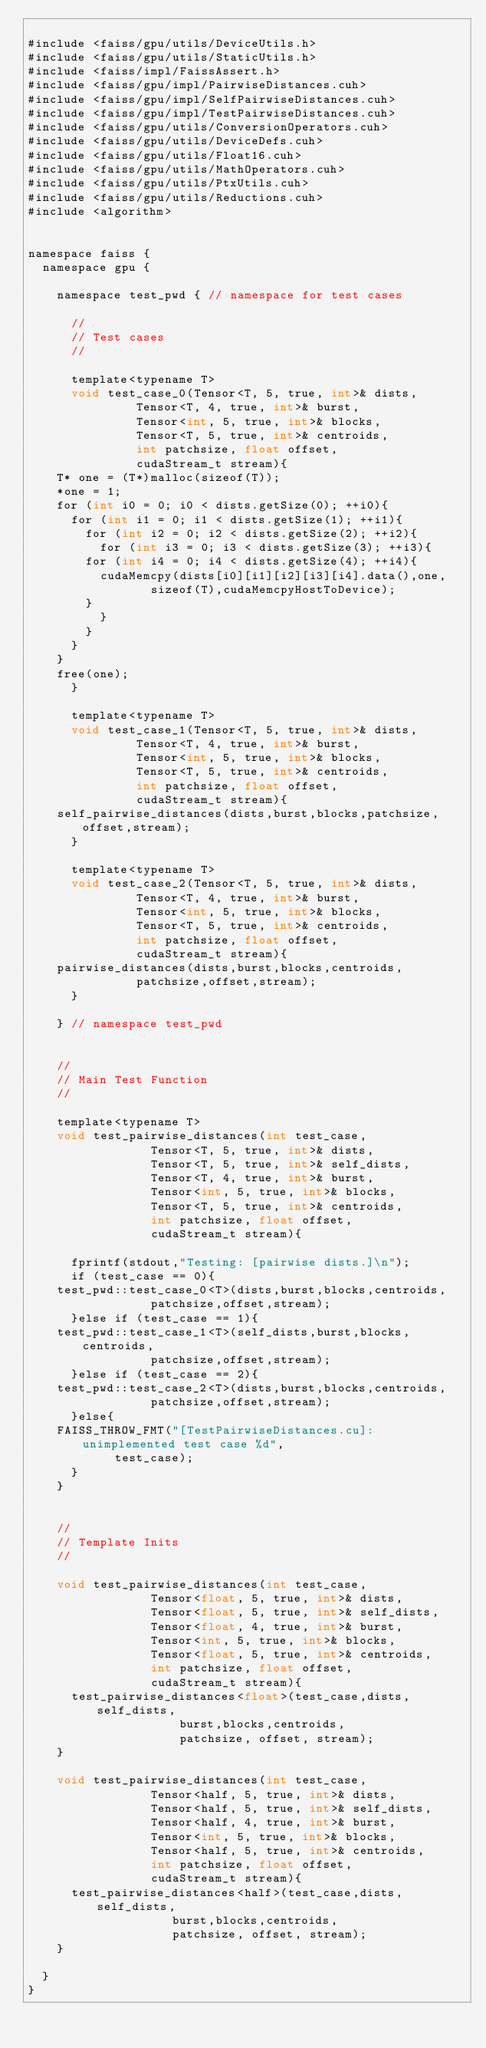<code> <loc_0><loc_0><loc_500><loc_500><_Cuda_>
#include <faiss/gpu/utils/DeviceUtils.h>
#include <faiss/gpu/utils/StaticUtils.h>
#include <faiss/impl/FaissAssert.h>
#include <faiss/gpu/impl/PairwiseDistances.cuh>
#include <faiss/gpu/impl/SelfPairwiseDistances.cuh>
#include <faiss/gpu/impl/TestPairwiseDistances.cuh>
#include <faiss/gpu/utils/ConversionOperators.cuh>
#include <faiss/gpu/utils/DeviceDefs.cuh>
#include <faiss/gpu/utils/Float16.cuh>
#include <faiss/gpu/utils/MathOperators.cuh>
#include <faiss/gpu/utils/PtxUtils.cuh>
#include <faiss/gpu/utils/Reductions.cuh>
#include <algorithm>


namespace faiss {
  namespace gpu {

    namespace test_pwd { // namespace for test cases
      
      //
      // Test cases
      //

      template<typename T>
      void test_case_0(Tensor<T, 5, true, int>& dists,
		       Tensor<T, 4, true, int>& burst,
		       Tensor<int, 5, true, int>& blocks,
		       Tensor<T, 5, true, int>& centroids,
		       int patchsize, float offset,
		       cudaStream_t stream){
	T* one = (T*)malloc(sizeof(T));
	*one = 1;
	for (int i0 = 0; i0 < dists.getSize(0); ++i0){
	  for (int i1 = 0; i1 < dists.getSize(1); ++i1){
	    for (int i2 = 0; i2 < dists.getSize(2); ++i2){
	      for (int i3 = 0; i3 < dists.getSize(3); ++i3){
		for (int i4 = 0; i4 < dists.getSize(4); ++i4){
		  cudaMemcpy(dists[i0][i1][i2][i3][i4].data(),one,
			     sizeof(T),cudaMemcpyHostToDevice);
		}
	      }
	    }
	  }
	}
	free(one);
      }

      template<typename T>
      void test_case_1(Tensor<T, 5, true, int>& dists,
		       Tensor<T, 4, true, int>& burst,
		       Tensor<int, 5, true, int>& blocks,
		       Tensor<T, 5, true, int>& centroids,
		       int patchsize, float offset,
		       cudaStream_t stream){
	self_pairwise_distances(dists,burst,blocks,patchsize,offset,stream);
      }

      template<typename T>
      void test_case_2(Tensor<T, 5, true, int>& dists,
		       Tensor<T, 4, true, int>& burst,
		       Tensor<int, 5, true, int>& blocks,
		       Tensor<T, 5, true, int>& centroids,
		       int patchsize, float offset,
		       cudaStream_t stream){
	pairwise_distances(dists,burst,blocks,centroids,
			   patchsize,offset,stream);
      }

    } // namespace test_pwd
    

    //
    // Main Test Function 
    //

    template<typename T>
    void test_pairwise_distances(int test_case,
				 Tensor<T, 5, true, int>& dists,
				 Tensor<T, 5, true, int>& self_dists,
				 Tensor<T, 4, true, int>& burst,
				 Tensor<int, 5, true, int>& blocks,
				 Tensor<T, 5, true, int>& centroids,
				 int patchsize, float offset,
				 cudaStream_t stream){

      fprintf(stdout,"Testing: [pairwise dists.]\n");
      if (test_case == 0){
	test_pwd::test_case_0<T>(dists,burst,blocks,centroids,
				 patchsize,offset,stream);
      }else if (test_case == 1){
	test_pwd::test_case_1<T>(self_dists,burst,blocks,centroids,
				 patchsize,offset,stream);
      }else if (test_case == 2){
	test_pwd::test_case_2<T>(dists,burst,blocks,centroids,
				 patchsize,offset,stream);
      }else{
	FAISS_THROW_FMT("[TestPairwiseDistances.cu]: unimplemented test case %d",
			test_case);
      }
    }


    //
    // Template Inits
    //
    
    void test_pairwise_distances(int test_case,
				 Tensor<float, 5, true, int>& dists,
				 Tensor<float, 5, true, int>& self_dists,
				 Tensor<float, 4, true, int>& burst,
				 Tensor<int, 5, true, int>& blocks,
				 Tensor<float, 5, true, int>& centroids,
				 int patchsize, float offset,
				 cudaStream_t stream){
      test_pairwise_distances<float>(test_case,dists,self_dists,
				     burst,blocks,centroids,
				     patchsize, offset, stream);
    }

    void test_pairwise_distances(int test_case,
				 Tensor<half, 5, true, int>& dists,
				 Tensor<half, 5, true, int>& self_dists,
				 Tensor<half, 4, true, int>& burst,
				 Tensor<int, 5, true, int>& blocks,
				 Tensor<half, 5, true, int>& centroids,
				 int patchsize, float offset,
				 cudaStream_t stream){
      test_pairwise_distances<half>(test_case,dists,self_dists,
				    burst,blocks,centroids,
				    patchsize, offset, stream);
    }

  }
}</code> 